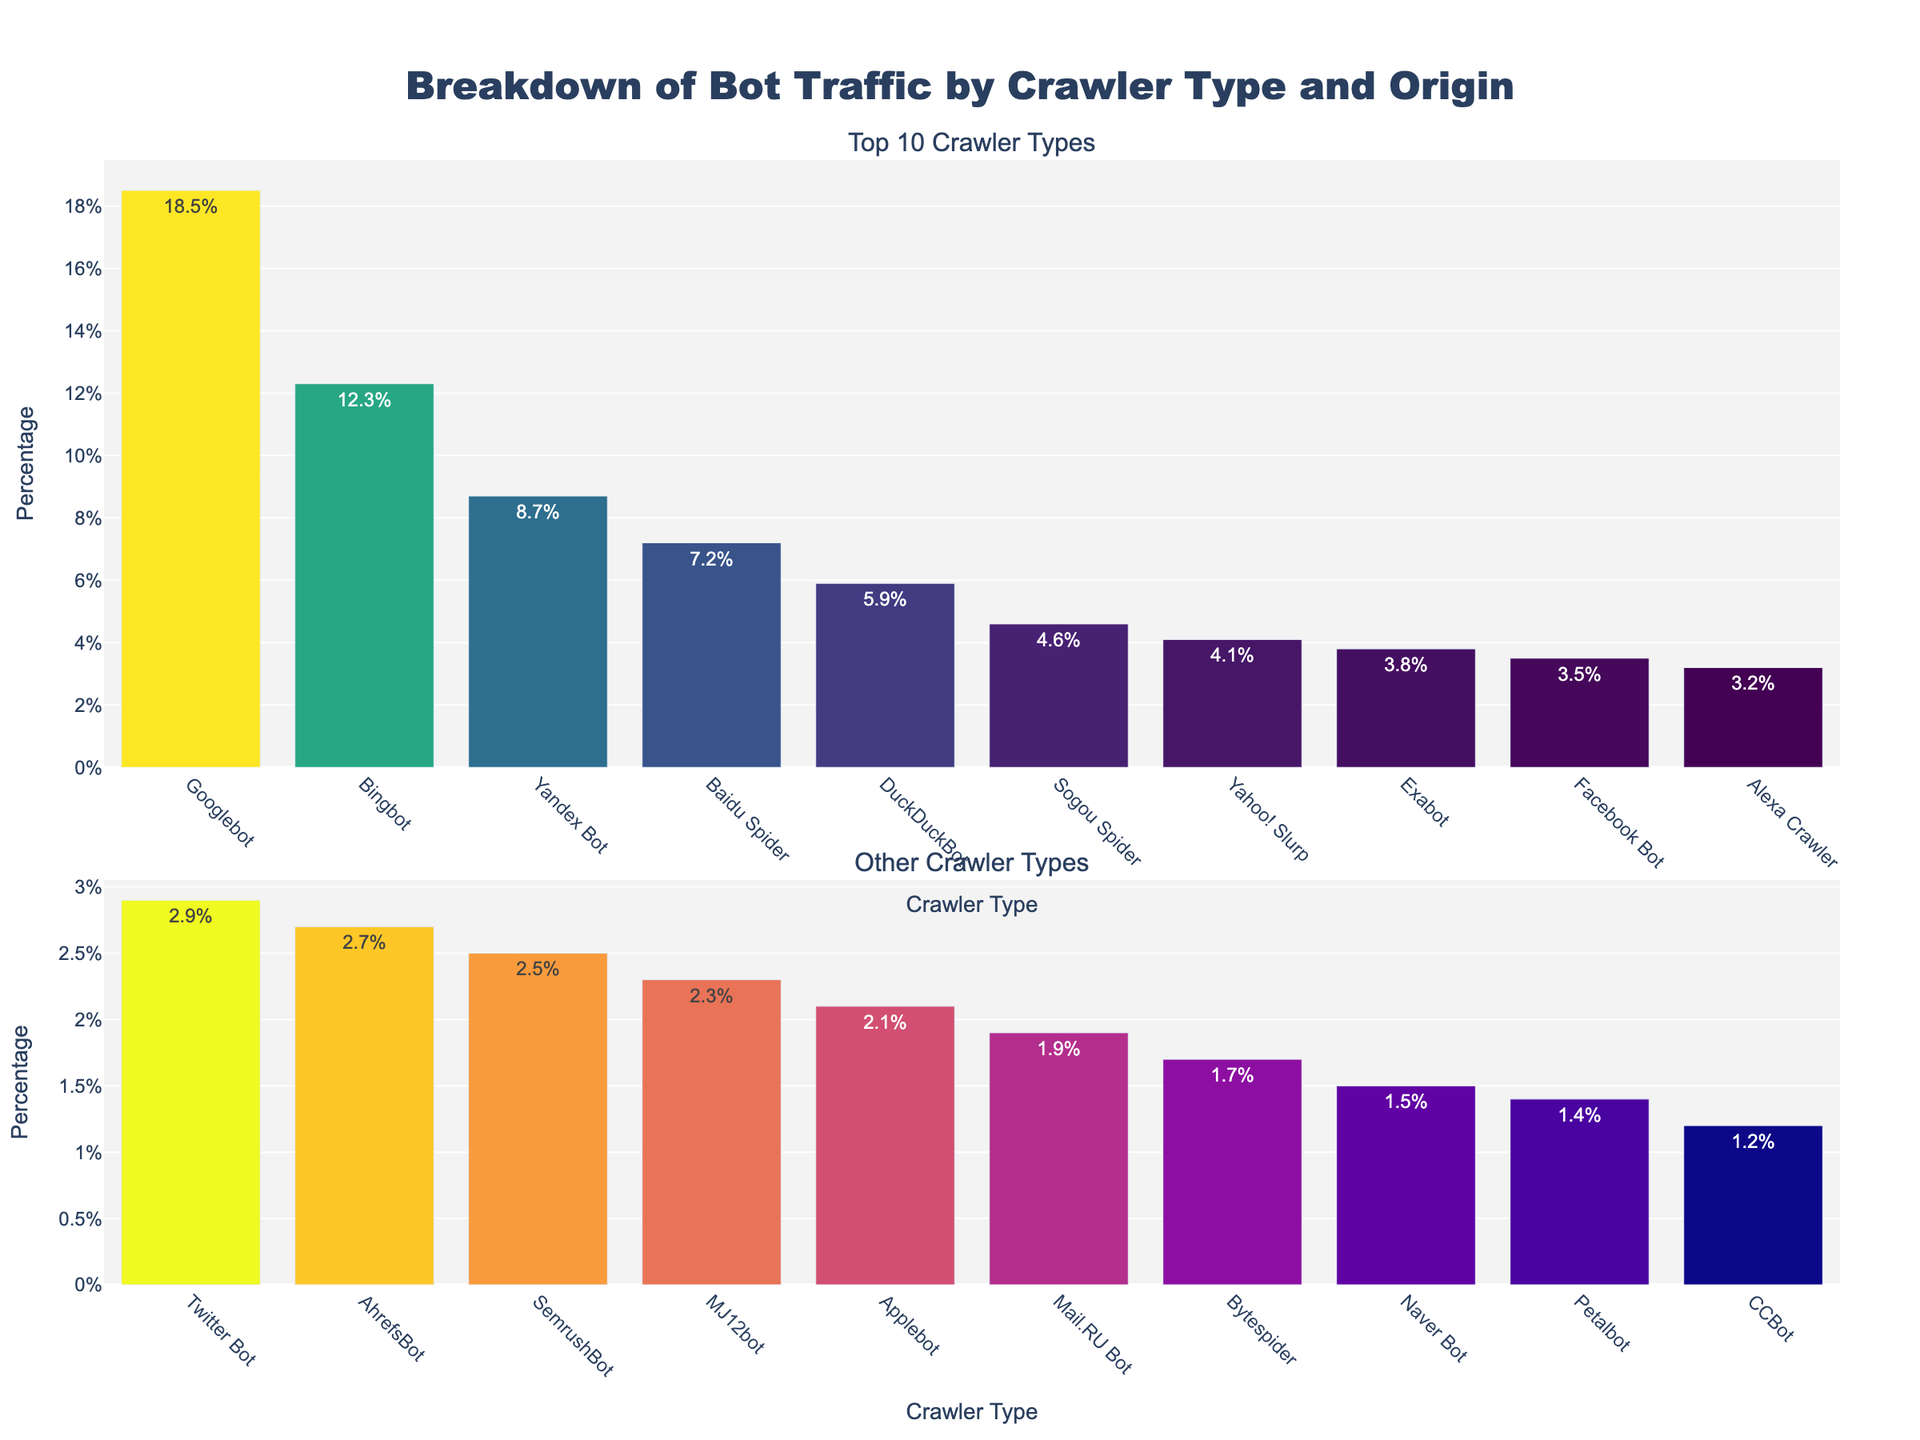What is the percentage of traffic from Googlebot? The first bar in the top subplot represents Googlebot, and it shows a height related to 18.5% traffic. The exact percentage is labeled directly on the bar as "18.5%".
Answer: 18.5% Which crawler type has the second-highest percentage of traffic from the US? By looking at the top 10 crawler types in the first row, observe the bars labeled with origins. After Googlebot (18.5% from the US), Bingbot has the second-highest traffic from the US at 12.3%.
Answer: Bingbot What is the combined percentage of the top 3 crawlers by traffic? The top 3 crawlers are Googlebot (18.5%), Bingbot (12.3%), and Yandex Bot (8.7%). Summing these values: 18.5 + 12.3 + 8.7 = 39.5%.
Answer: 39.5% Which crawler type from China has the highest traffic percentage? From the bars in both subplots, identify the entries with "China" as the origin. Baidu Spider is from China and has a percentage of 7.2%, which is higher than Sogou Spider with 4.6%.
Answer: Baidu Spider What is the difference in traffic percentage between the highest and lowest traffic crawlers in the top 10? The highest traffic in the top 10 is Googlebot at 18.5%, and the lowest is Yahoo! Slurp at 4.1%. Subtracting the lowest from the highest: 18.5 - 4.1 = 14.4%.
Answer: 14.4% Which crawler type from Russia has the second-highest percentage of traffic? From the bars labeled with "Russia" as the origin, Yandex Bot (8.7%) has the highest, followed by Mail.RU Bot (1.9%).
Answer: Mail.RU Bot What is the average percentage of traffic for all crawler types in the bottom subplot? To find the mean of the percentages in the bottom subplot, add the percentages (3.5 + 3.2 + 2.9 + 2.7 + 2.5 + 2.3 + 2.1 + 1.9 + 1.7 + 1.5 + 1.4 + 1.2) and divide by the number of entries. The sum is 29.9 and there are 12 crawlers, so 29.9 / 12 = 2.5%.
Answer: 2.5% How many crawler types originate from the US? By counting the bars with "US" as the origin tag in both subplots, we get: Googlebot, Bingbot, DuckDuckBot, Yahoo! Slurp, Facebook Bot, Alexa Crawler, Twitter Bot, Applebot, and CCBot, giving a total of 9.
Answer: 9 